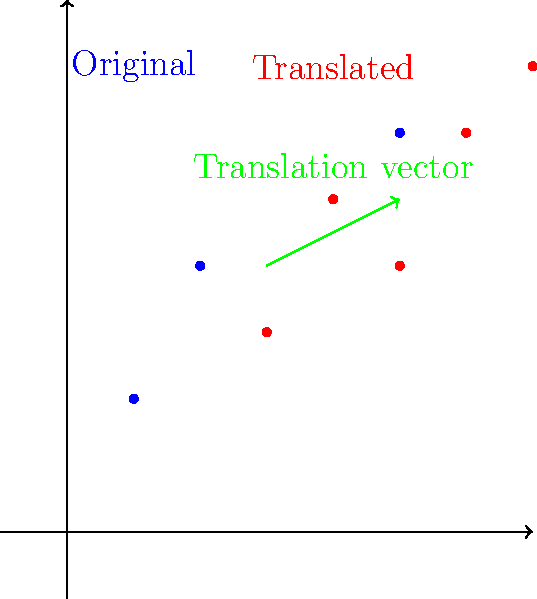As a product manager, you're analyzing user engagement metrics. You have a scatter plot of data points representing various engagement indicators. To better visualize trends, you need to translate this plot by a vector $(2, 1)$. If the original coordinates of one data point were $(3, 4)$, what would be its new coordinates after the translation? To solve this problem, we need to understand the concept of translation in transformational geometry and how it applies to our scatter plot:

1. Translation is a transformation that moves every point of a figure by the same distance in a given direction.

2. The translation vector $(2, 1)$ means we move 2 units in the positive x-direction and 1 unit in the positive y-direction.

3. To translate a point, we add the components of the translation vector to the coordinates of the original point.

4. The original point has coordinates $(3, 4)$.

5. To translate this point:
   - New x-coordinate = Original x-coordinate + x-component of translation vector
   - New y-coordinate = Original y-coordinate + y-component of translation vector

6. Calculating the new coordinates:
   - New x-coordinate = $3 + 2 = 5$
   - New y-coordinate = $4 + 1 = 5$

Therefore, the new coordinates of the point after translation are $(5, 5)$.
Answer: $(5, 5)$ 